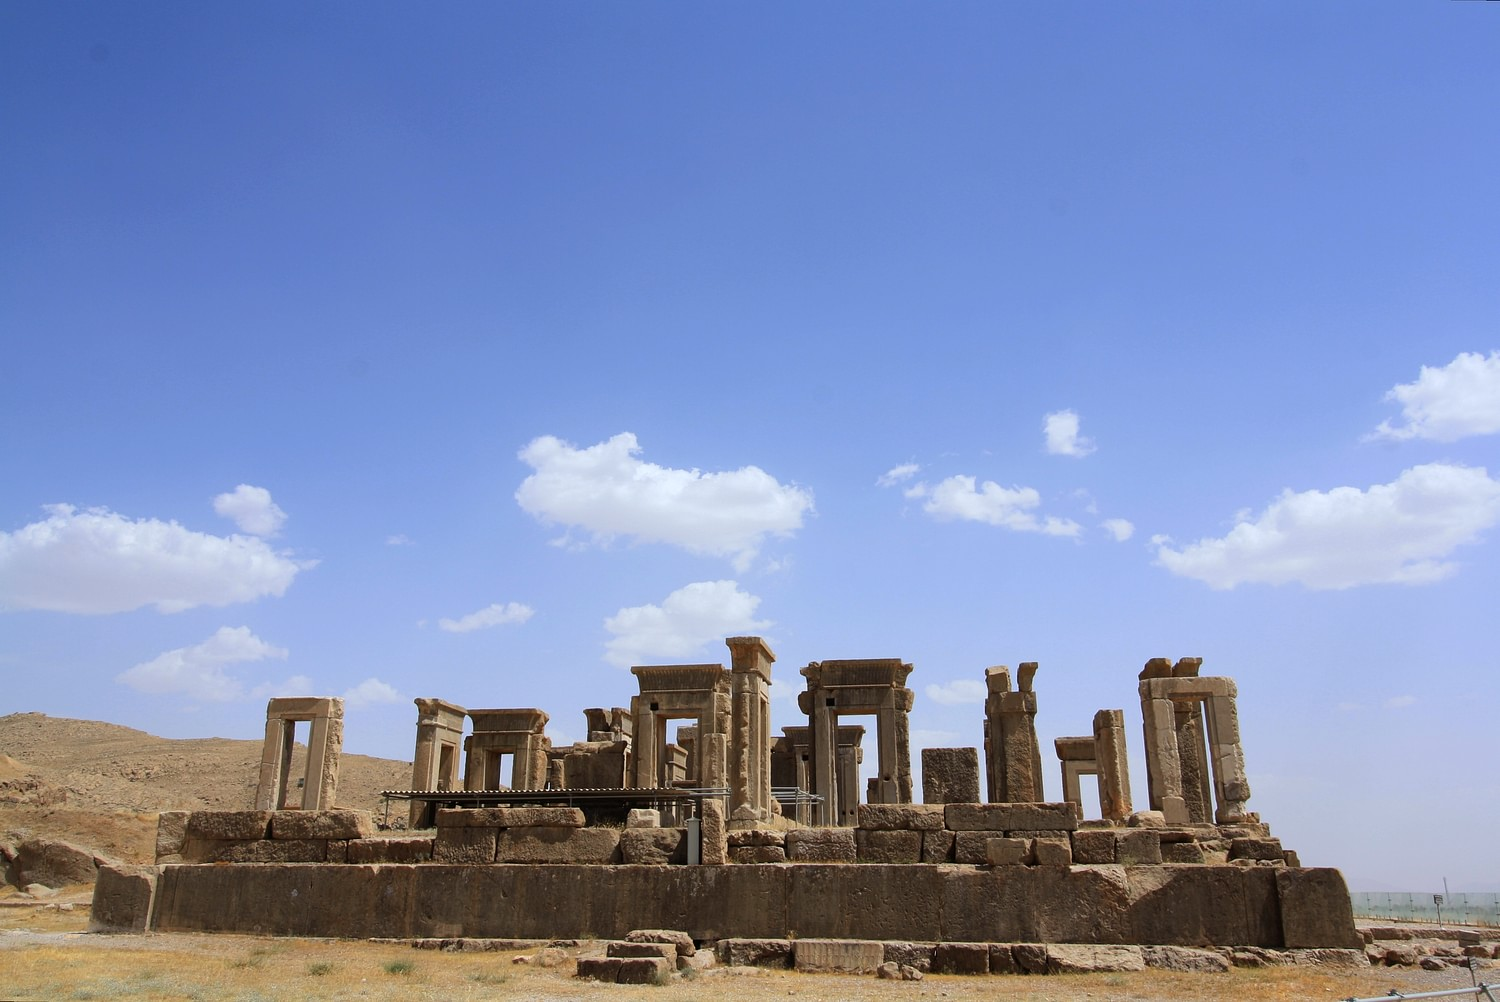Can you tell me more about Persepolis' architectural style? Certainly! Persepolis is renowned for its grandiose architecture, which is a hallmark of Achaemenid design. The site features massive columns with elaborate capitals, expansive staircases, and the use of impressive reliefs to depict historical narratives and glorify the king. Iconic aspects include the use of rectangular terraces, the integration of natural landscape into the layout, and the use of durable materials like limestone. This architectural approach not only displayed the empire’s wealth and power but also served functional purposes, supporting the structure's longevity and aesthetic appeal. 